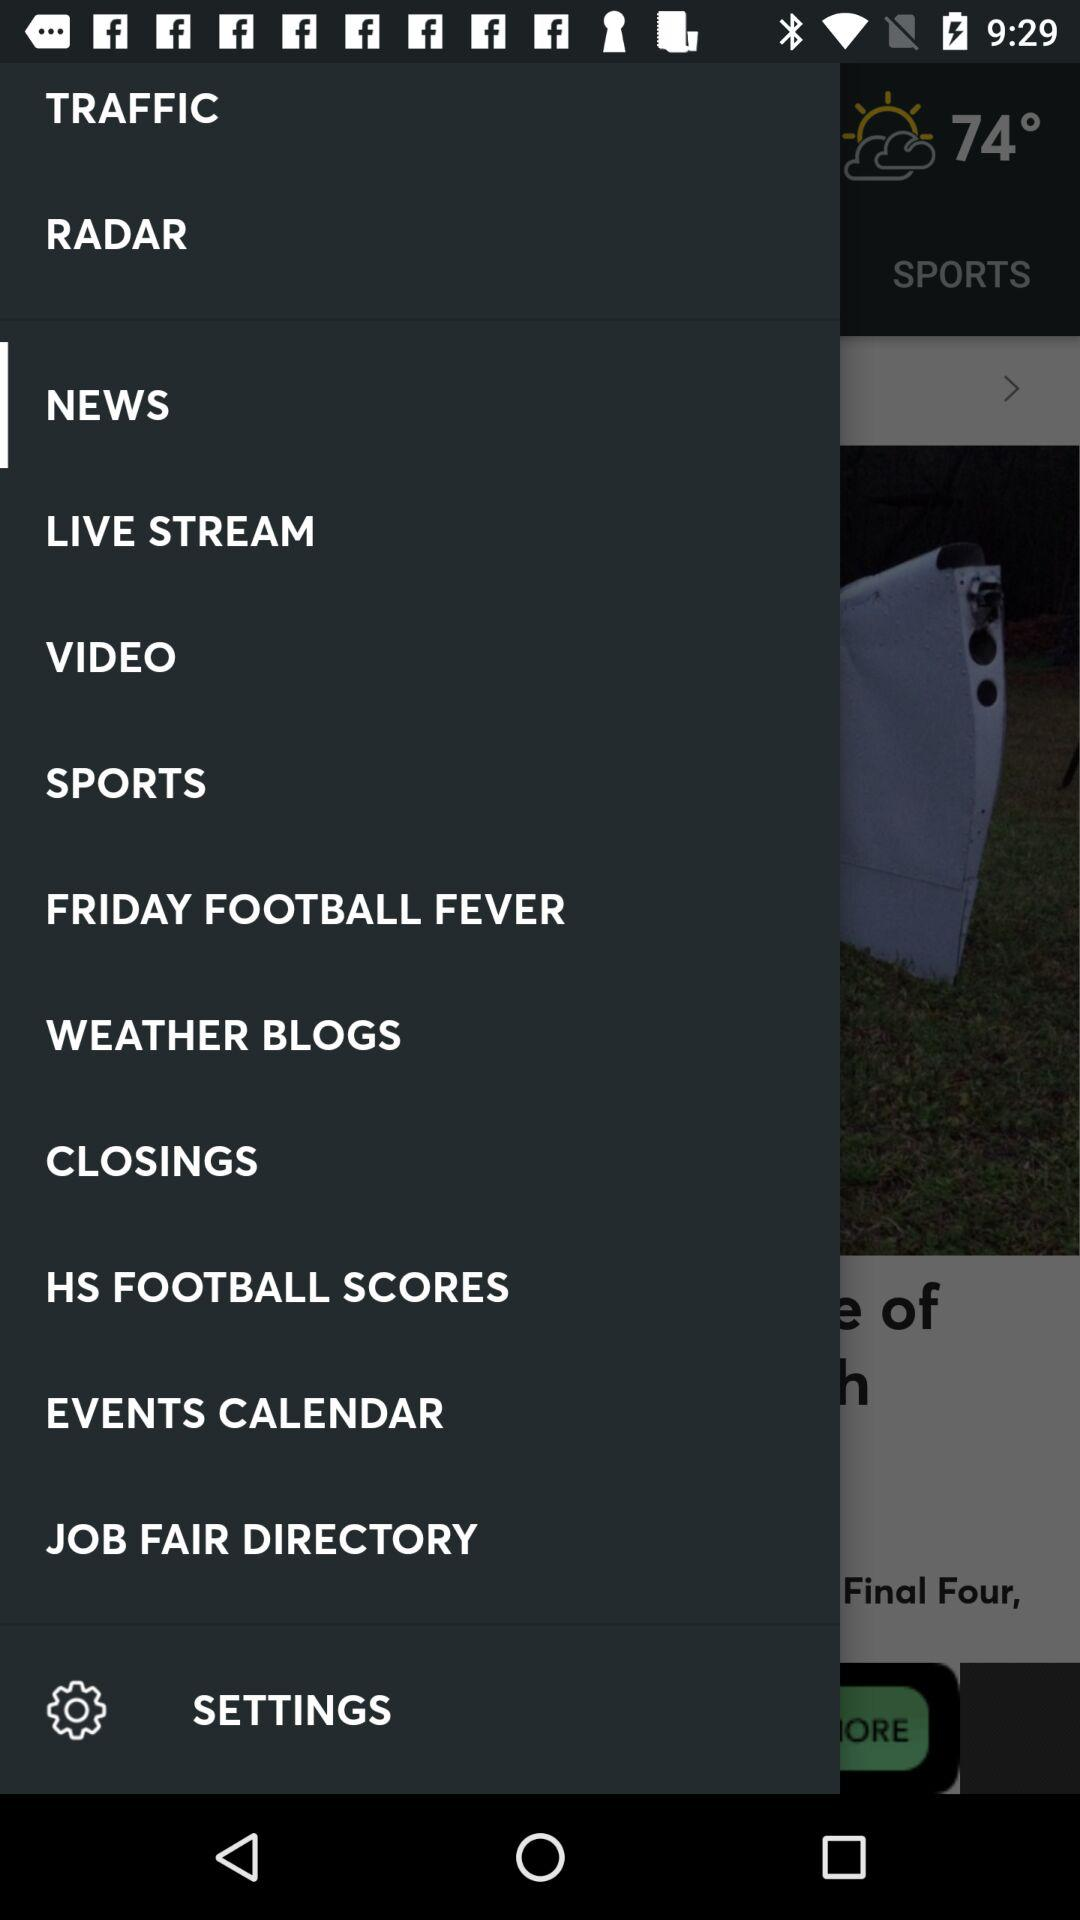What is the temperature? The temperature is 74 degrees. 